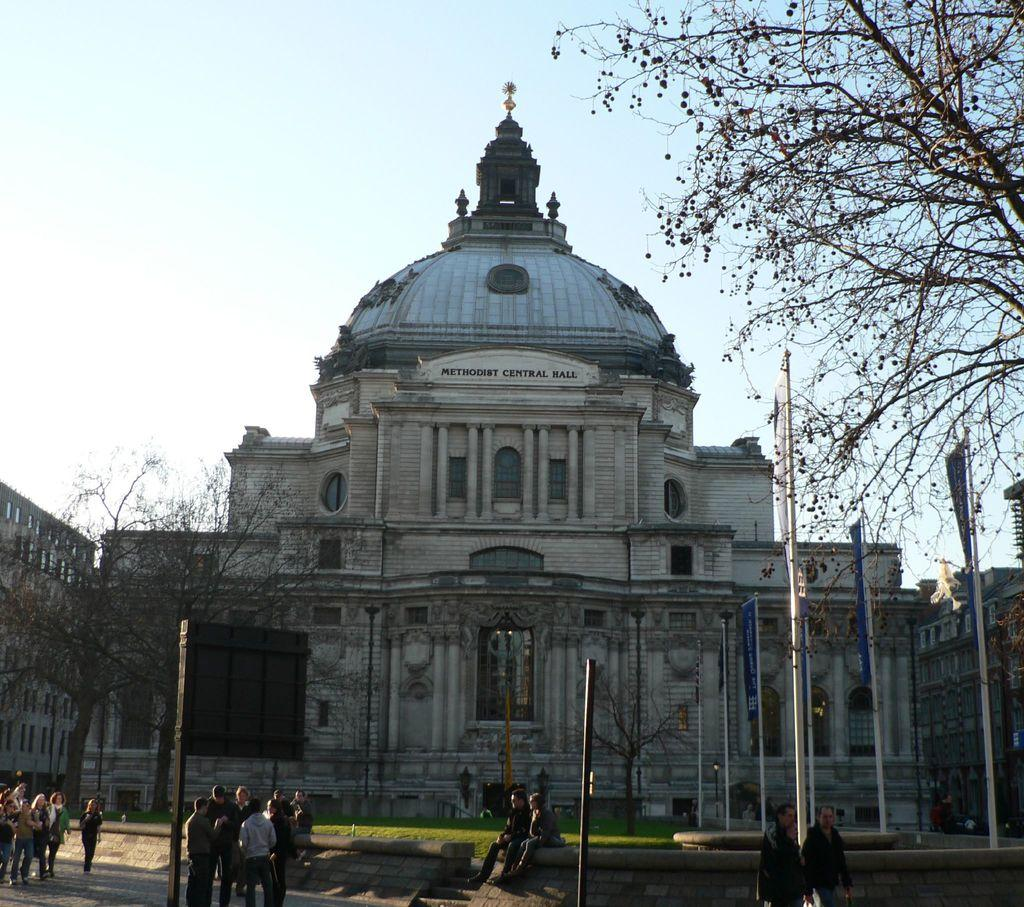What type of structure is visible in the image? There is a building in the image. What objects are present in the image that are used for support or guidance? There are poles in the image. What type of vegetation can be seen in the image? There are trees in the image. Can you describe the people in the image? There are people standing and people seated in the image. What is the ground covered with in the image? There is grass on the ground in the image. How would you describe the weather based on the image? The sky is cloudy in the image. What type of pan is being used by the visitor in the image? There is no pan or visitor present in the image. What knowledge is being shared among the people in the image? The image does not provide any information about knowledge being shared among the people. 